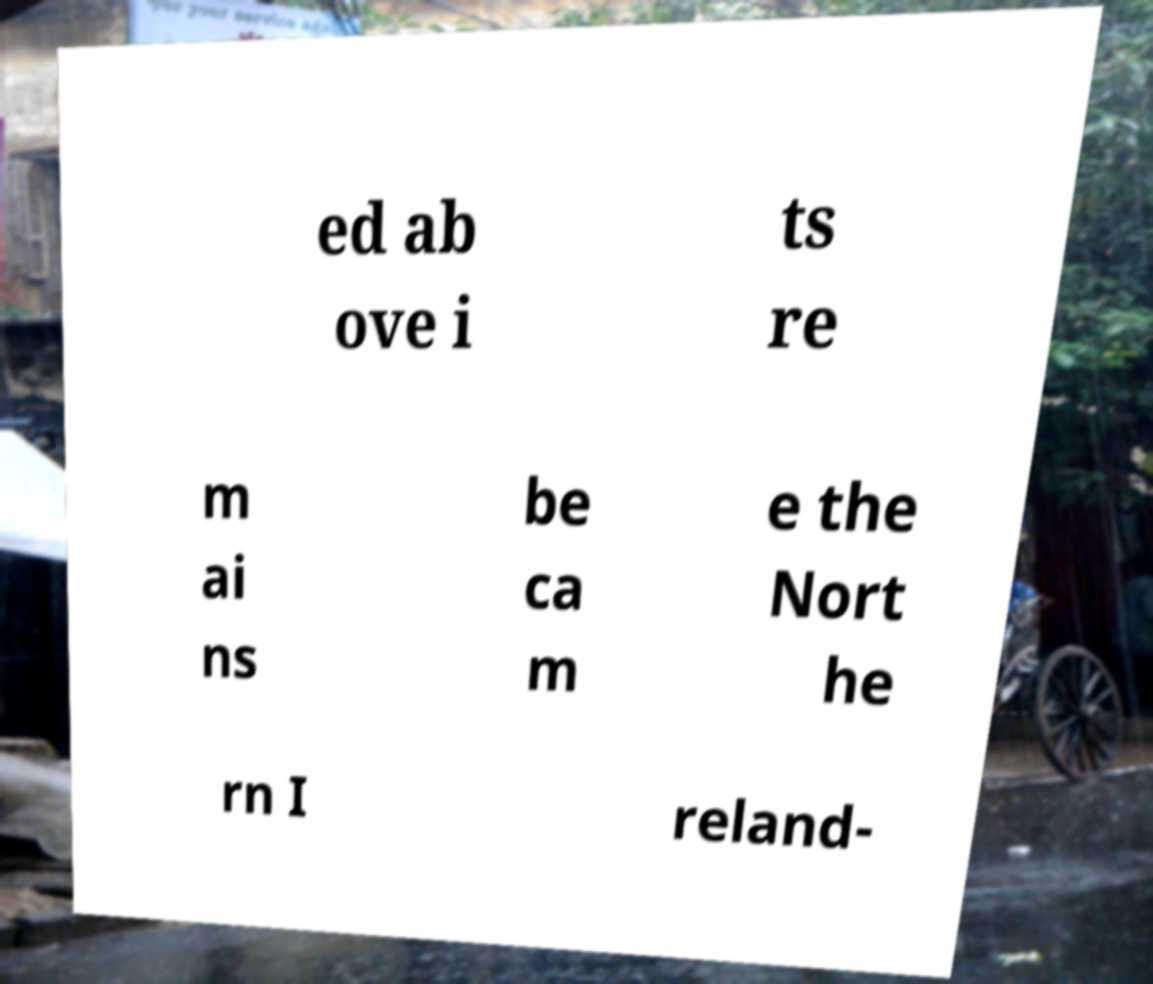What messages or text are displayed in this image? I need them in a readable, typed format. ed ab ove i ts re m ai ns be ca m e the Nort he rn I reland- 